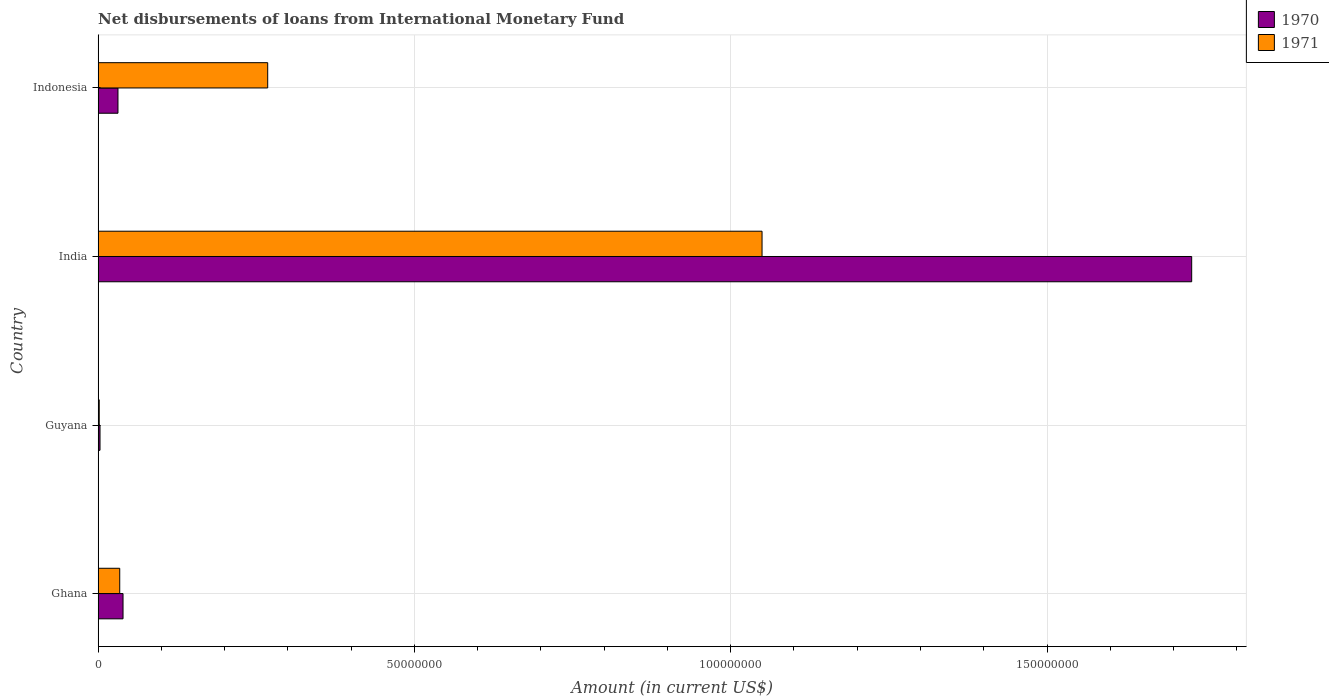How many groups of bars are there?
Your response must be concise. 4. Are the number of bars per tick equal to the number of legend labels?
Provide a succinct answer. Yes. Are the number of bars on each tick of the Y-axis equal?
Offer a terse response. Yes. How many bars are there on the 4th tick from the top?
Your response must be concise. 2. How many bars are there on the 4th tick from the bottom?
Give a very brief answer. 2. What is the label of the 3rd group of bars from the top?
Your response must be concise. Guyana. In how many cases, is the number of bars for a given country not equal to the number of legend labels?
Provide a succinct answer. 0. What is the amount of loans disbursed in 1970 in Ghana?
Provide a succinct answer. 3.94e+06. Across all countries, what is the maximum amount of loans disbursed in 1970?
Ensure brevity in your answer.  1.73e+08. Across all countries, what is the minimum amount of loans disbursed in 1970?
Provide a succinct answer. 2.99e+05. In which country was the amount of loans disbursed in 1970 maximum?
Provide a short and direct response. India. In which country was the amount of loans disbursed in 1971 minimum?
Keep it short and to the point. Guyana. What is the total amount of loans disbursed in 1971 in the graph?
Keep it short and to the point. 1.35e+08. What is the difference between the amount of loans disbursed in 1970 in India and that in Indonesia?
Give a very brief answer. 1.70e+08. What is the difference between the amount of loans disbursed in 1971 in Guyana and the amount of loans disbursed in 1970 in India?
Your response must be concise. -1.73e+08. What is the average amount of loans disbursed in 1970 per country?
Provide a short and direct response. 4.51e+07. What is the difference between the amount of loans disbursed in 1971 and amount of loans disbursed in 1970 in India?
Provide a succinct answer. -6.79e+07. What is the ratio of the amount of loans disbursed in 1971 in Guyana to that in Indonesia?
Offer a very short reply. 0.01. Is the amount of loans disbursed in 1970 in Guyana less than that in India?
Keep it short and to the point. Yes. What is the difference between the highest and the second highest amount of loans disbursed in 1971?
Your answer should be compact. 7.81e+07. What is the difference between the highest and the lowest amount of loans disbursed in 1971?
Provide a short and direct response. 1.05e+08. In how many countries, is the amount of loans disbursed in 1971 greater than the average amount of loans disbursed in 1971 taken over all countries?
Your answer should be very brief. 1. Are all the bars in the graph horizontal?
Keep it short and to the point. Yes. How many countries are there in the graph?
Offer a terse response. 4. Does the graph contain any zero values?
Ensure brevity in your answer.  No. How many legend labels are there?
Ensure brevity in your answer.  2. What is the title of the graph?
Offer a terse response. Net disbursements of loans from International Monetary Fund. Does "2005" appear as one of the legend labels in the graph?
Provide a short and direct response. No. What is the label or title of the Y-axis?
Provide a succinct answer. Country. What is the Amount (in current US$) in 1970 in Ghana?
Make the answer very short. 3.94e+06. What is the Amount (in current US$) in 1971 in Ghana?
Keep it short and to the point. 3.42e+06. What is the Amount (in current US$) of 1970 in Guyana?
Offer a terse response. 2.99e+05. What is the Amount (in current US$) of 1971 in Guyana?
Offer a terse response. 1.76e+05. What is the Amount (in current US$) of 1970 in India?
Provide a succinct answer. 1.73e+08. What is the Amount (in current US$) of 1971 in India?
Ensure brevity in your answer.  1.05e+08. What is the Amount (in current US$) of 1970 in Indonesia?
Keep it short and to the point. 3.14e+06. What is the Amount (in current US$) in 1971 in Indonesia?
Your answer should be very brief. 2.68e+07. Across all countries, what is the maximum Amount (in current US$) in 1970?
Give a very brief answer. 1.73e+08. Across all countries, what is the maximum Amount (in current US$) in 1971?
Offer a very short reply. 1.05e+08. Across all countries, what is the minimum Amount (in current US$) in 1970?
Give a very brief answer. 2.99e+05. Across all countries, what is the minimum Amount (in current US$) in 1971?
Your answer should be compact. 1.76e+05. What is the total Amount (in current US$) of 1970 in the graph?
Your answer should be compact. 1.80e+08. What is the total Amount (in current US$) of 1971 in the graph?
Offer a very short reply. 1.35e+08. What is the difference between the Amount (in current US$) in 1970 in Ghana and that in Guyana?
Provide a short and direct response. 3.64e+06. What is the difference between the Amount (in current US$) of 1971 in Ghana and that in Guyana?
Ensure brevity in your answer.  3.24e+06. What is the difference between the Amount (in current US$) in 1970 in Ghana and that in India?
Offer a terse response. -1.69e+08. What is the difference between the Amount (in current US$) in 1971 in Ghana and that in India?
Give a very brief answer. -1.02e+08. What is the difference between the Amount (in current US$) of 1970 in Ghana and that in Indonesia?
Provide a short and direct response. 7.99e+05. What is the difference between the Amount (in current US$) in 1971 in Ghana and that in Indonesia?
Give a very brief answer. -2.34e+07. What is the difference between the Amount (in current US$) in 1970 in Guyana and that in India?
Offer a very short reply. -1.73e+08. What is the difference between the Amount (in current US$) in 1971 in Guyana and that in India?
Ensure brevity in your answer.  -1.05e+08. What is the difference between the Amount (in current US$) in 1970 in Guyana and that in Indonesia?
Provide a succinct answer. -2.84e+06. What is the difference between the Amount (in current US$) of 1971 in Guyana and that in Indonesia?
Ensure brevity in your answer.  -2.66e+07. What is the difference between the Amount (in current US$) of 1970 in India and that in Indonesia?
Make the answer very short. 1.70e+08. What is the difference between the Amount (in current US$) in 1971 in India and that in Indonesia?
Ensure brevity in your answer.  7.81e+07. What is the difference between the Amount (in current US$) of 1970 in Ghana and the Amount (in current US$) of 1971 in Guyana?
Make the answer very short. 3.76e+06. What is the difference between the Amount (in current US$) in 1970 in Ghana and the Amount (in current US$) in 1971 in India?
Your response must be concise. -1.01e+08. What is the difference between the Amount (in current US$) of 1970 in Ghana and the Amount (in current US$) of 1971 in Indonesia?
Ensure brevity in your answer.  -2.29e+07. What is the difference between the Amount (in current US$) of 1970 in Guyana and the Amount (in current US$) of 1971 in India?
Your response must be concise. -1.05e+08. What is the difference between the Amount (in current US$) in 1970 in Guyana and the Amount (in current US$) in 1971 in Indonesia?
Offer a terse response. -2.65e+07. What is the difference between the Amount (in current US$) in 1970 in India and the Amount (in current US$) in 1971 in Indonesia?
Ensure brevity in your answer.  1.46e+08. What is the average Amount (in current US$) in 1970 per country?
Provide a short and direct response. 4.51e+07. What is the average Amount (in current US$) in 1971 per country?
Offer a very short reply. 3.38e+07. What is the difference between the Amount (in current US$) of 1970 and Amount (in current US$) of 1971 in Ghana?
Give a very brief answer. 5.20e+05. What is the difference between the Amount (in current US$) in 1970 and Amount (in current US$) in 1971 in Guyana?
Offer a very short reply. 1.23e+05. What is the difference between the Amount (in current US$) in 1970 and Amount (in current US$) in 1971 in India?
Your answer should be compact. 6.79e+07. What is the difference between the Amount (in current US$) in 1970 and Amount (in current US$) in 1971 in Indonesia?
Your answer should be compact. -2.37e+07. What is the ratio of the Amount (in current US$) of 1970 in Ghana to that in Guyana?
Make the answer very short. 13.17. What is the ratio of the Amount (in current US$) of 1971 in Ghana to that in Guyana?
Offer a terse response. 19.42. What is the ratio of the Amount (in current US$) in 1970 in Ghana to that in India?
Ensure brevity in your answer.  0.02. What is the ratio of the Amount (in current US$) in 1971 in Ghana to that in India?
Give a very brief answer. 0.03. What is the ratio of the Amount (in current US$) in 1970 in Ghana to that in Indonesia?
Provide a succinct answer. 1.25. What is the ratio of the Amount (in current US$) in 1971 in Ghana to that in Indonesia?
Provide a short and direct response. 0.13. What is the ratio of the Amount (in current US$) of 1970 in Guyana to that in India?
Ensure brevity in your answer.  0. What is the ratio of the Amount (in current US$) of 1971 in Guyana to that in India?
Offer a very short reply. 0. What is the ratio of the Amount (in current US$) in 1970 in Guyana to that in Indonesia?
Provide a succinct answer. 0.1. What is the ratio of the Amount (in current US$) of 1971 in Guyana to that in Indonesia?
Your answer should be compact. 0.01. What is the ratio of the Amount (in current US$) of 1970 in India to that in Indonesia?
Provide a short and direct response. 55.07. What is the ratio of the Amount (in current US$) of 1971 in India to that in Indonesia?
Provide a succinct answer. 3.91. What is the difference between the highest and the second highest Amount (in current US$) of 1970?
Provide a succinct answer. 1.69e+08. What is the difference between the highest and the second highest Amount (in current US$) of 1971?
Make the answer very short. 7.81e+07. What is the difference between the highest and the lowest Amount (in current US$) of 1970?
Ensure brevity in your answer.  1.73e+08. What is the difference between the highest and the lowest Amount (in current US$) of 1971?
Your answer should be compact. 1.05e+08. 